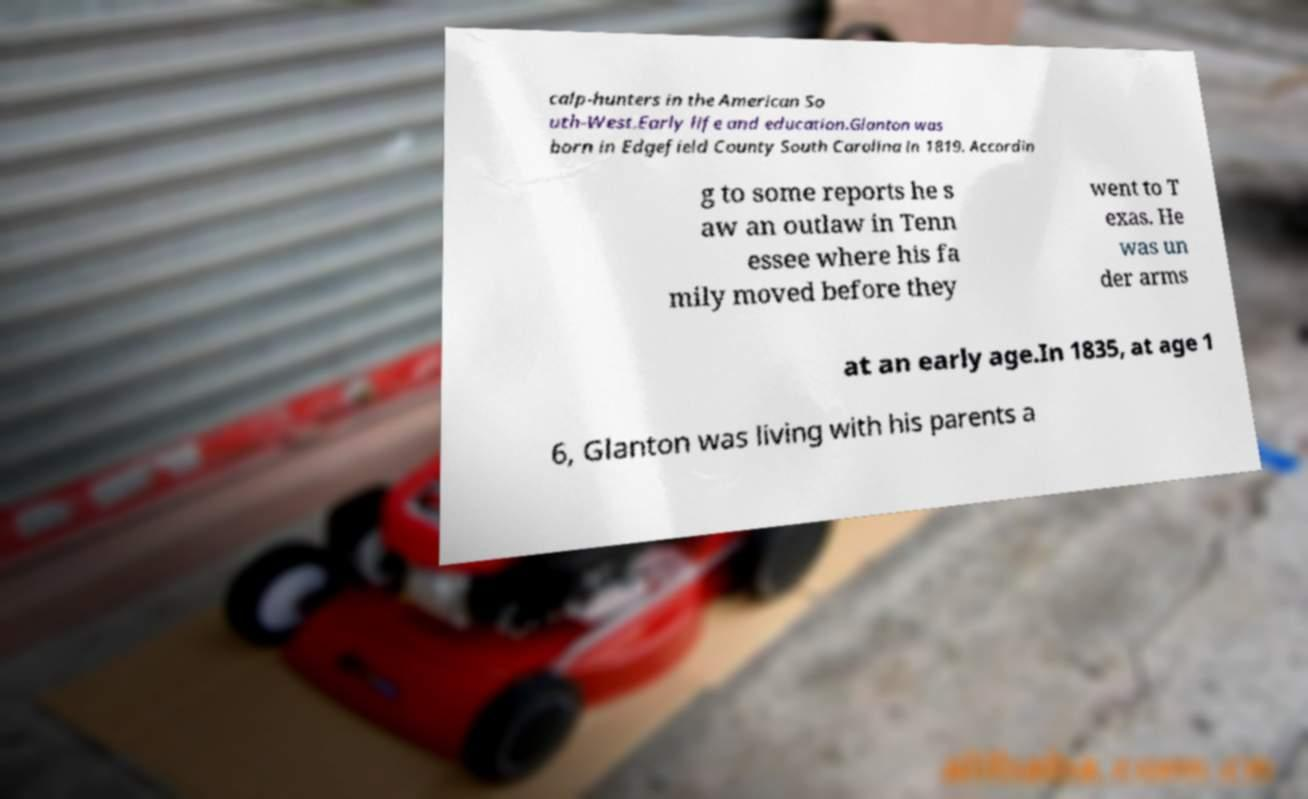Could you assist in decoding the text presented in this image and type it out clearly? calp-hunters in the American So uth-West.Early life and education.Glanton was born in Edgefield County South Carolina in 1819. Accordin g to some reports he s aw an outlaw in Tenn essee where his fa mily moved before they went to T exas. He was un der arms at an early age.In 1835, at age 1 6, Glanton was living with his parents a 